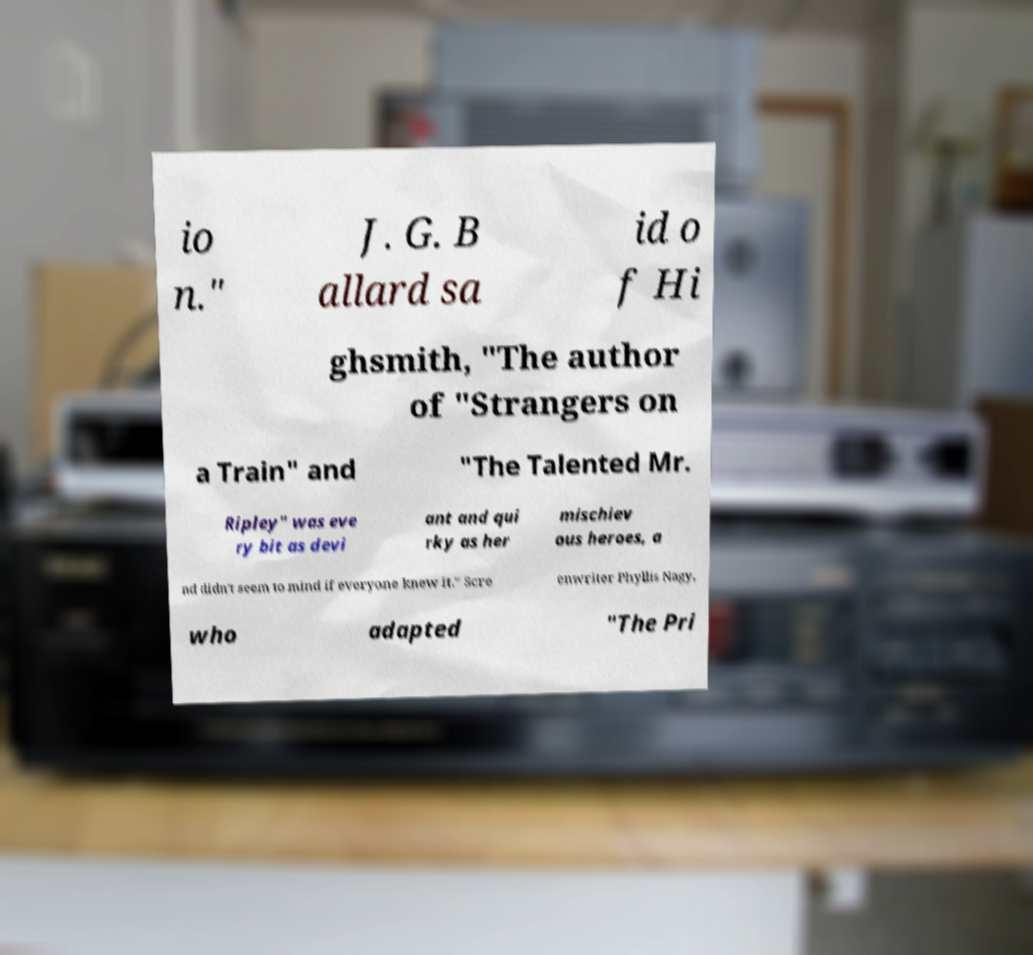I need the written content from this picture converted into text. Can you do that? io n." J. G. B allard sa id o f Hi ghsmith, "The author of "Strangers on a Train" and "The Talented Mr. Ripley" was eve ry bit as devi ant and qui rky as her mischiev ous heroes, a nd didn't seem to mind if everyone knew it." Scre enwriter Phyllis Nagy, who adapted "The Pri 